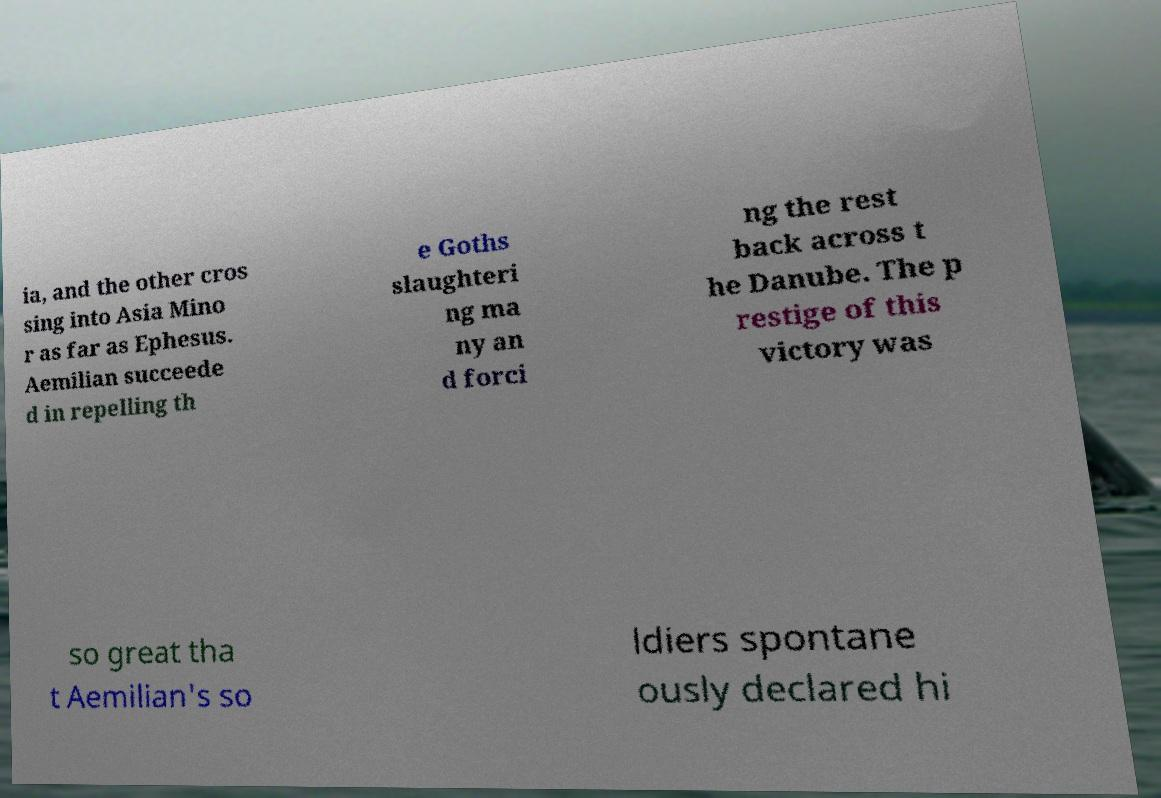For documentation purposes, I need the text within this image transcribed. Could you provide that? ia, and the other cros sing into Asia Mino r as far as Ephesus. Aemilian succeede d in repelling th e Goths slaughteri ng ma ny an d forci ng the rest back across t he Danube. The p restige of this victory was so great tha t Aemilian's so ldiers spontane ously declared hi 